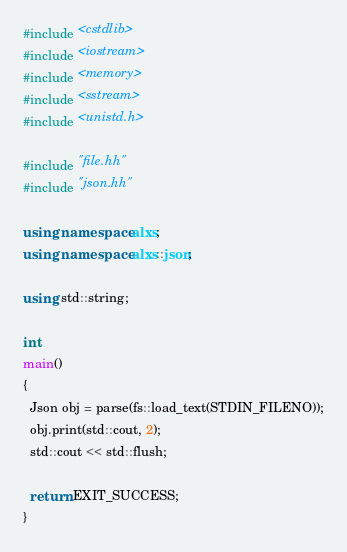Convert code to text. <code><loc_0><loc_0><loc_500><loc_500><_C++_>#include <cstdlib>
#include <iostream>
#include <memory>
#include <sstream>
#include <unistd.h>

#include "file.hh"
#include "json.hh"

using namespace alxs;
using namespace alxs::json;

using std::string;

int 
main()
{
  Json obj = parse(fs::load_text(STDIN_FILENO));
  obj.print(std::cout, 2);
  std::cout << std::flush;

  return EXIT_SUCCESS;
}


</code> 